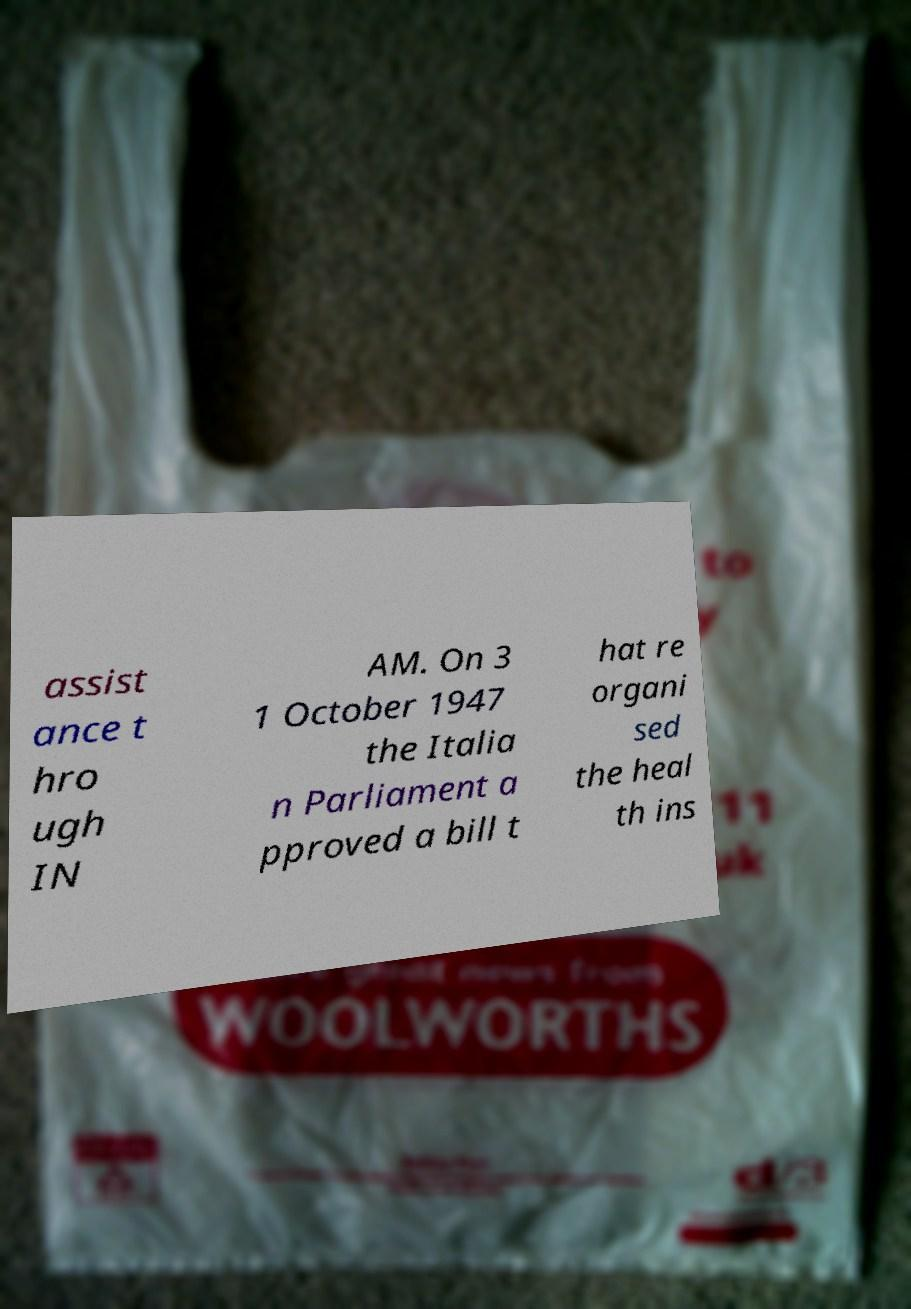What messages or text are displayed in this image? I need them in a readable, typed format. assist ance t hro ugh IN AM. On 3 1 October 1947 the Italia n Parliament a pproved a bill t hat re organi sed the heal th ins 